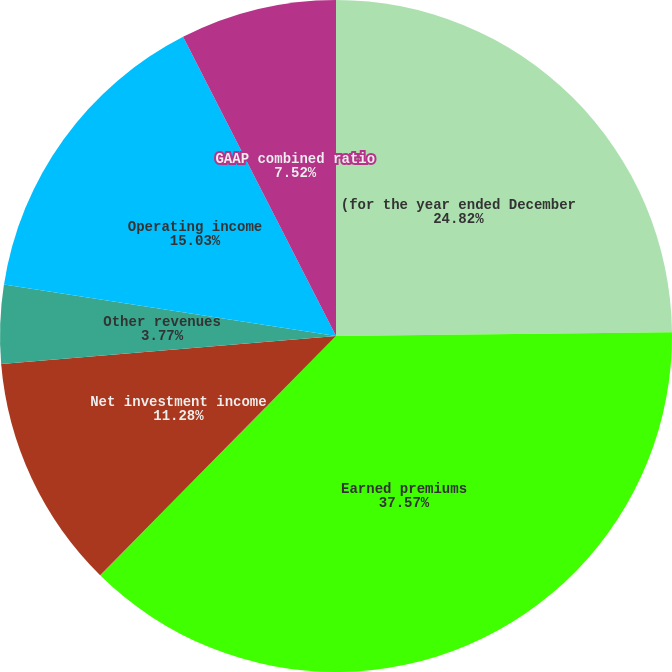Convert chart. <chart><loc_0><loc_0><loc_500><loc_500><pie_chart><fcel>(for the year ended December<fcel>Earned premiums<fcel>Net investment income<fcel>Fee income<fcel>Other revenues<fcel>Operating income<fcel>GAAP combined ratio<nl><fcel>24.82%<fcel>37.56%<fcel>11.28%<fcel>0.01%<fcel>3.77%<fcel>15.03%<fcel>7.52%<nl></chart> 